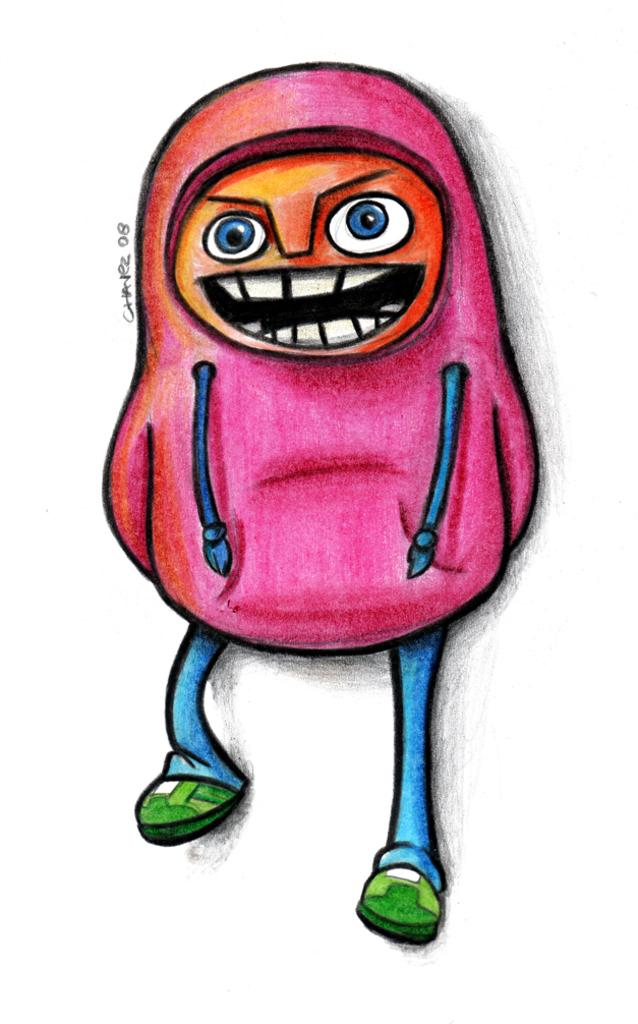What type of image is present in the picture? There is a cartoon image in the picture. How many legs does the cartoon image have? The cartoon image has two legs. How many hands does the cartoon image have? The cartoon image has two hands. What facial features can be seen on the cartoon image? The cartoon image has a face. How many potatoes are visible in the image? There are no potatoes present in the image. Can you describe the hill in the background of the image? There is no hill visible in the image; it features a cartoon image with no background elements mentioned. 